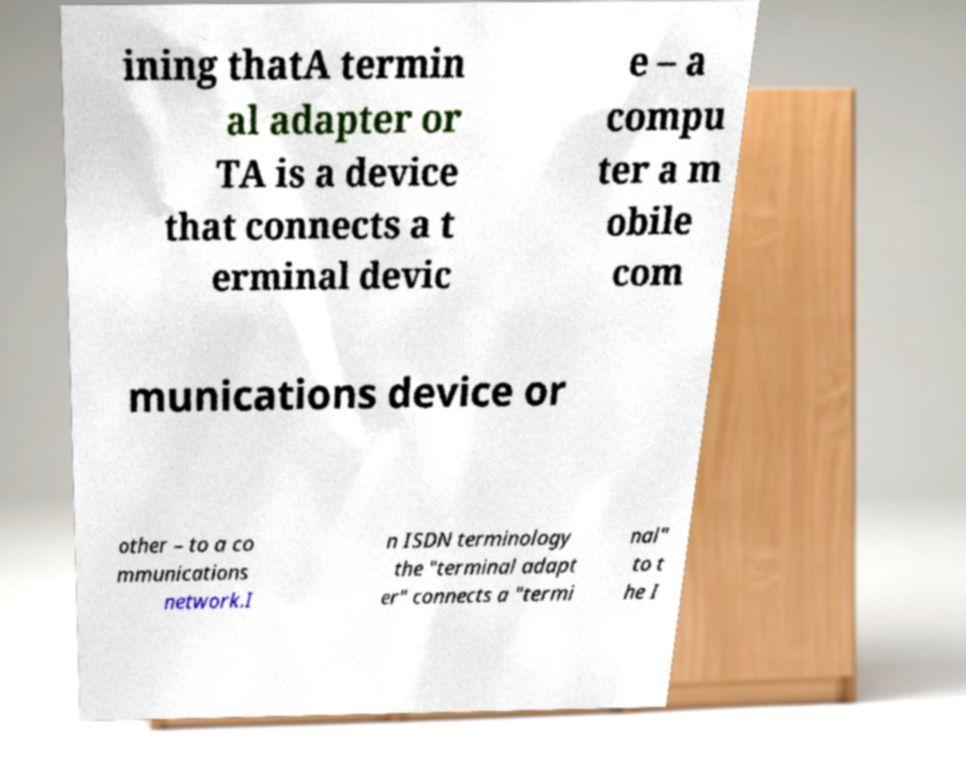For documentation purposes, I need the text within this image transcribed. Could you provide that? ining thatA termin al adapter or TA is a device that connects a t erminal devic e – a compu ter a m obile com munications device or other – to a co mmunications network.I n ISDN terminology the "terminal adapt er" connects a "termi nal" to t he I 